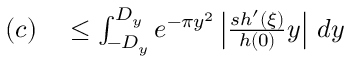<formula> <loc_0><loc_0><loc_500><loc_500>\begin{array} { r l } { ( c ) } & \leq \int _ { - D _ { y } } ^ { D _ { y } } e ^ { - \pi y ^ { 2 } } \left | { \frac { s h ^ { \prime } ( \xi ) } { h ( 0 ) } } y \right | \, d y } \end{array}</formula> 